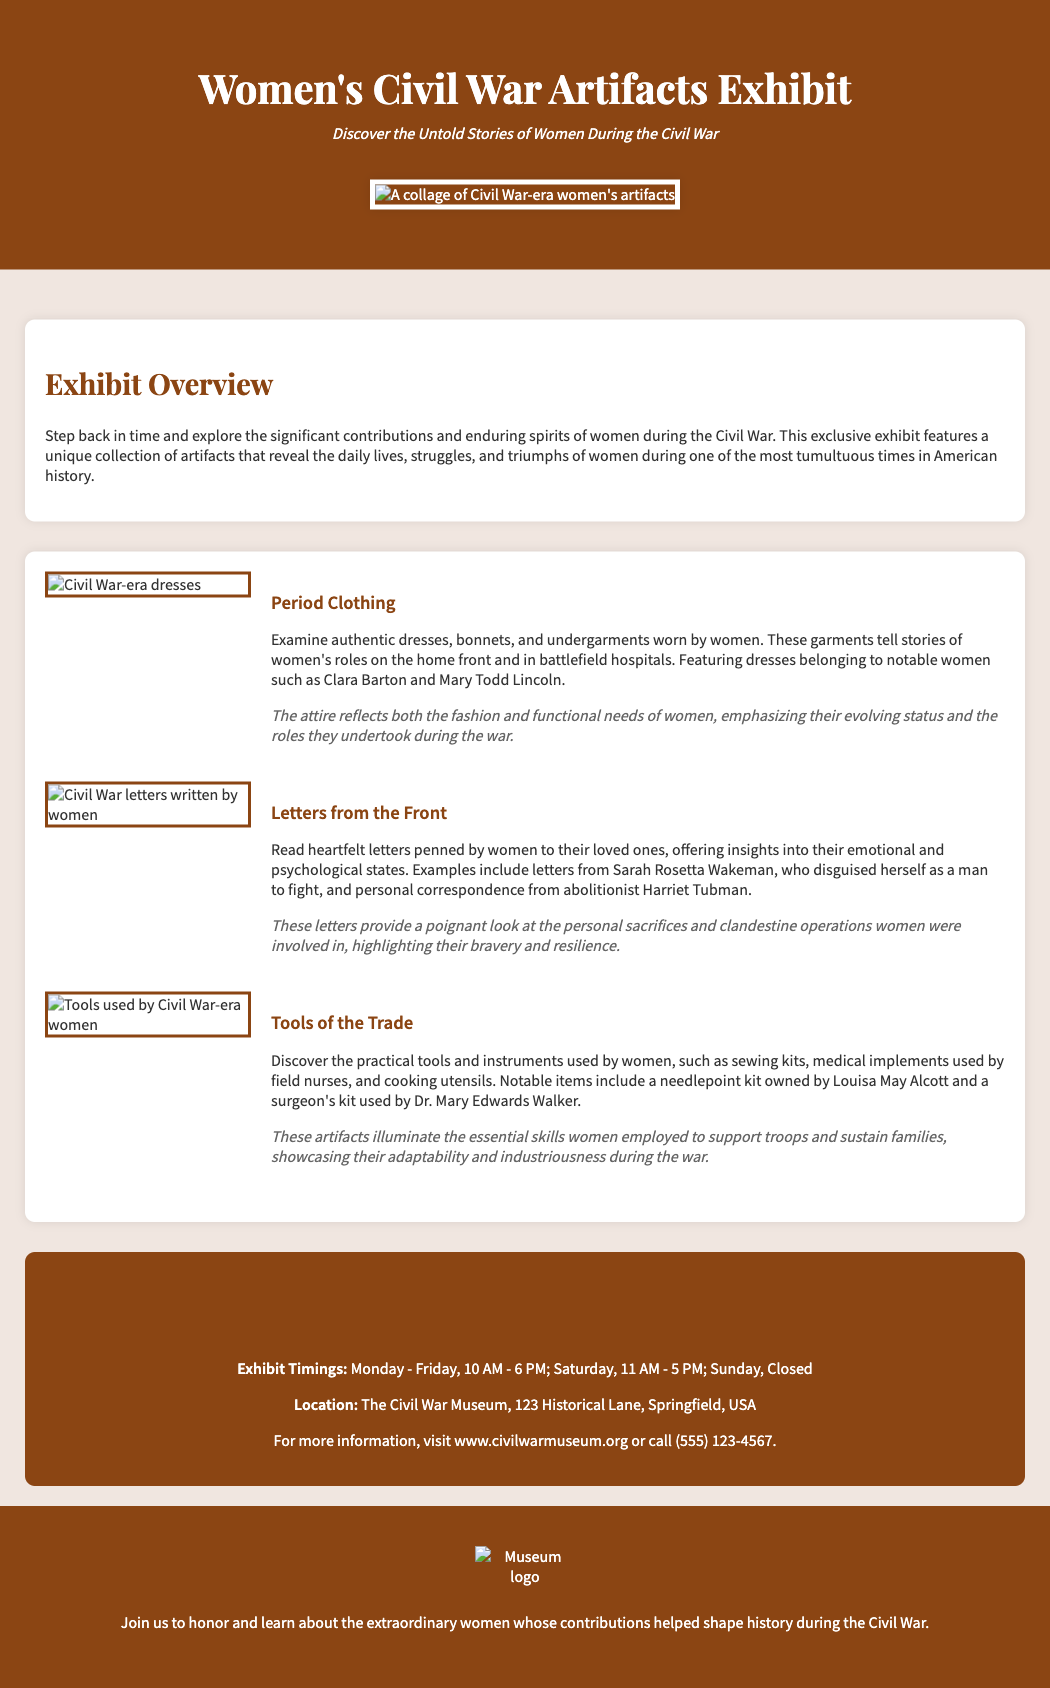What is the title of the exhibit? The title of the exhibit is highlighted at the top of the document, prominently displayed as "Women's Civil War Artifacts Exhibit."
Answer: Women's Civil War Artifacts Exhibit What is the location of the exhibit? The location is specified in the document under the visit section.
Answer: The Civil War Museum, 123 Historical Lane, Springfield, USA What day is the exhibit closed? The details section indicates which day the museum is not open.
Answer: Sunday Which notable woman’s items are featured in the clothing section? The document mentions notable women whose clothing items are included in the exhibit.
Answer: Clara Barton and Mary Todd Lincoln What is the main theme of the exhibit? The overview section outlines the primary focus of the exhibit, emphasizing women's roles.
Answer: The significant contributions and enduring spirits of women during the Civil War How many days a week is the exhibit open? The exhibit timings section reveals the days the exhibit is accessible to visitors.
Answer: Six days What is one type of artifact displayed related to communications? The document describes various types of artifacts on display and identifies one relating to communication.
Answer: Letters from the Front What specific item was owned by Louisa May Alcott? The tools section provides specific examples of artifacts linked to notable individuals.
Answer: A needlepoint kit 